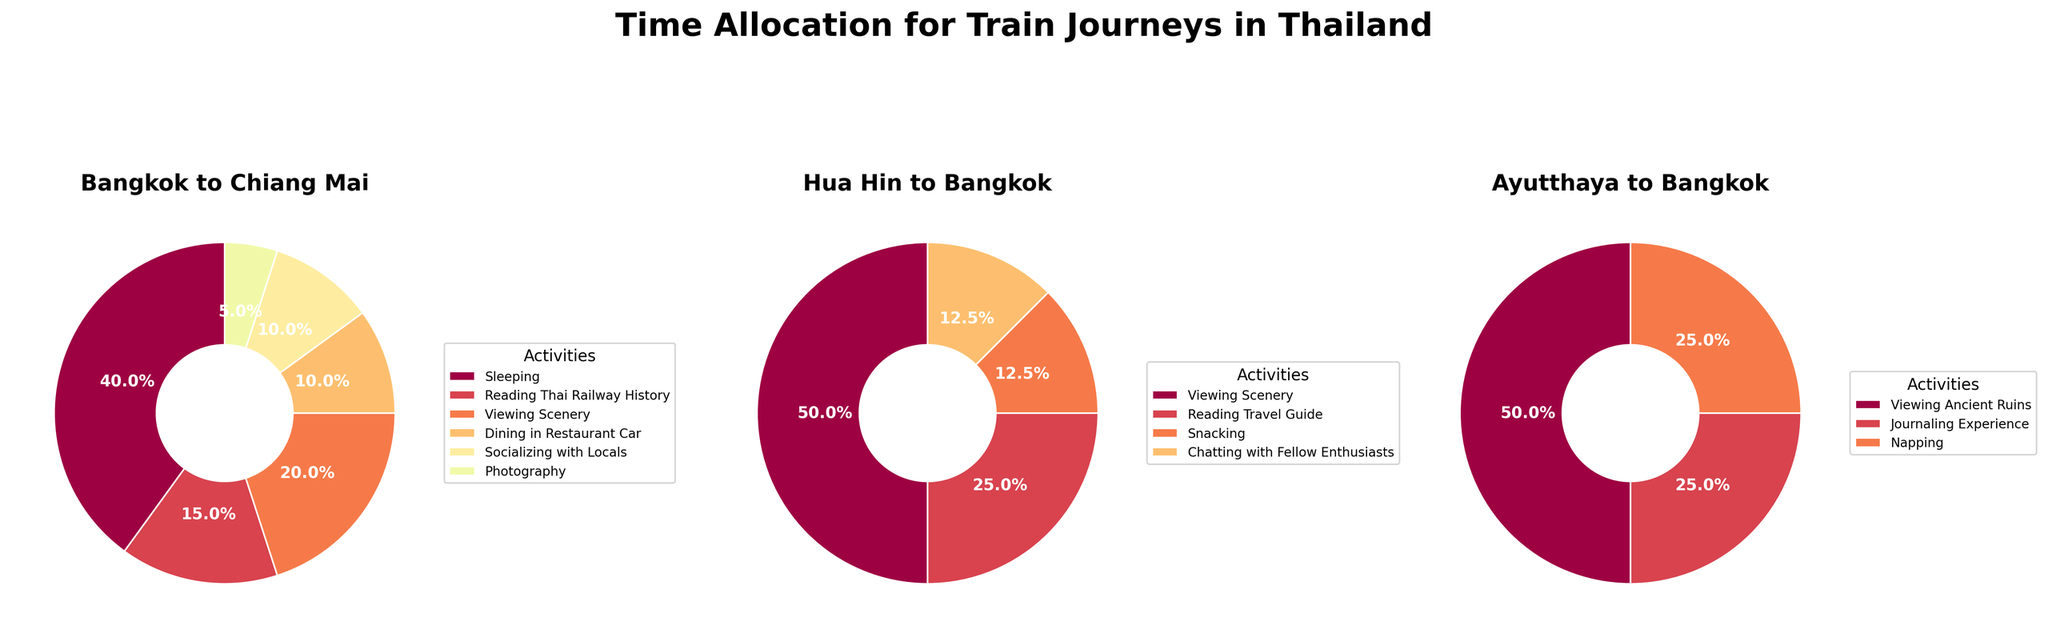What are the three journey types represented in the figure? The figure has three pie charts with each representing a different journey type. By reading the titles of these pie charts, we can identify the journey types.
Answer: Bangkok to Chiang Mai, Hua Hin to Bangkok, Ayutthaya to Bangkok Which activity takes the most time for the journey from Bangkok to Chiang Mai? By looking at the pie chart for Bangkok to Chiang Mai, we can observe the largest wedge, which represents the most time-consuming activity.
Answer: Sleeping What is the total time spent on activities for the journey from Hua Hin to Bangkok? The wedges in the pie chart for Hua Hin to Bangkok show the distribution of time among activities. Adding the times from the wedges provides the total time. 2 (Viewing Scenery) + 1 (Reading Travel Guide) + 0.5 (Snacking) + 0.5 (Chatting with Fellow Enthusiasts) = 4 hours.
Answer: 4 hours Which journey dedicates the least time to socializing activities? By comparing the pie charts for all three journeys, we identify the wedges labeled with social activities. Summing the times for these wedges and comparing allows us to determine the least time spent. Bangkok to Chiang Mai has 2 hours of socializing, Hua Hin to Bangkok has 0.5 hours of chatting, and Ayutthaya to Bangkok has no socializing activities.
Answer: Ayutthaya to Bangkok Which two activities collectively take up half of the journey time from Bangkok to Chiang Mai? Analyzing the pie chart for Bangkok to Chiang Mai, we see wedges labeled with their respective times. Adding the times of different combinations to find which ones sum up to 50% of the total time, which is 10 hours. Sleeping (8 hours) and Viewing Scenery (4 hours) together exceed half; the combination of Viewing Scenery (4 hours) and Reading Thai Railway History (3 hours) with neither other activities meets the 10-hour requirement.
Answer: Viewing Scenery and Reading Thai Railway History How does the time spent photographing compare between the journeys? By looking at each pie chart, we find the section labeled as photography. Only the journey from Bangkok to Chiang Mai shows time spent on photography (1 hour); the other two journeys have no wedge for photography.
Answer: Only Bangkok to Chiang Mai has time for photography What percentage of time is spent on napping during the journey from Ayutthaya to Bangkok? Check the wedge labeled "Napping" on the pie chart for Ayutthaya to Bangkok. The wedge indicates 0.5 hours out of a total of 2 hours. Calculating (0.5 / 2) * 100 results in the percentage.
Answer: 25% Which journey includes the activity of dining in the restaurant car, and how much time is allocated to it? By examining the pies, only Bangkok to Chiang Mai's chart has a wedge labeled 'Dining in the Restaurant Car'. We refer to that wedge to find the time.
Answer: Bangkok to Chiang Mai, 2 hours Which journey spends the most significant proportion on sightseeing activities? By comparing the proportions of wedges dedicated to activities like Viewing Scenery and Viewing Ancient Ruins across all three journeys, we find the largest proportion.
Answer: Bangkok to Chiang Mai 